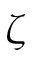<formula> <loc_0><loc_0><loc_500><loc_500>\zeta</formula> 